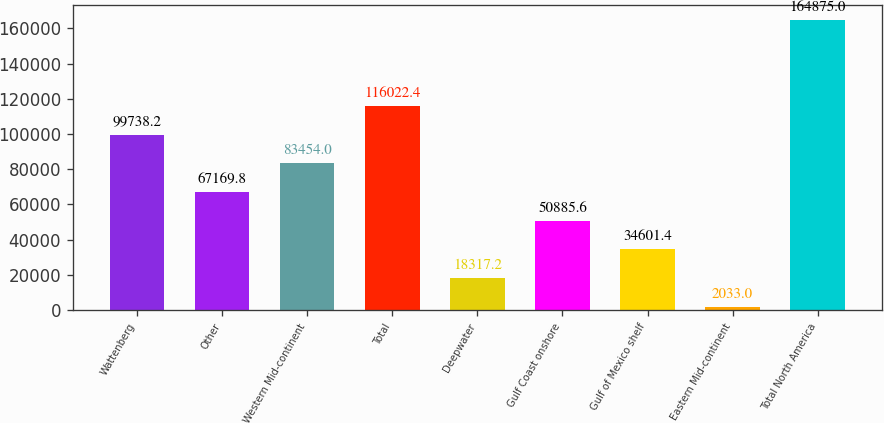Convert chart to OTSL. <chart><loc_0><loc_0><loc_500><loc_500><bar_chart><fcel>Wattenberg<fcel>Other<fcel>Western Mid-continent<fcel>Total<fcel>Deepwater<fcel>Gulf Coast onshore<fcel>Gulf of Mexico shelf<fcel>Eastern Mid-continent<fcel>Total North America<nl><fcel>99738.2<fcel>67169.8<fcel>83454<fcel>116022<fcel>18317.2<fcel>50885.6<fcel>34601.4<fcel>2033<fcel>164875<nl></chart> 